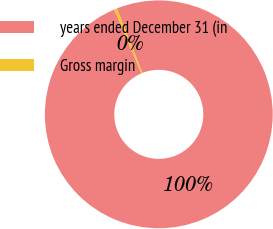<chart> <loc_0><loc_0><loc_500><loc_500><pie_chart><fcel>years ended December 31 (in<fcel>Gross margin<nl><fcel>99.6%<fcel>0.4%<nl></chart> 